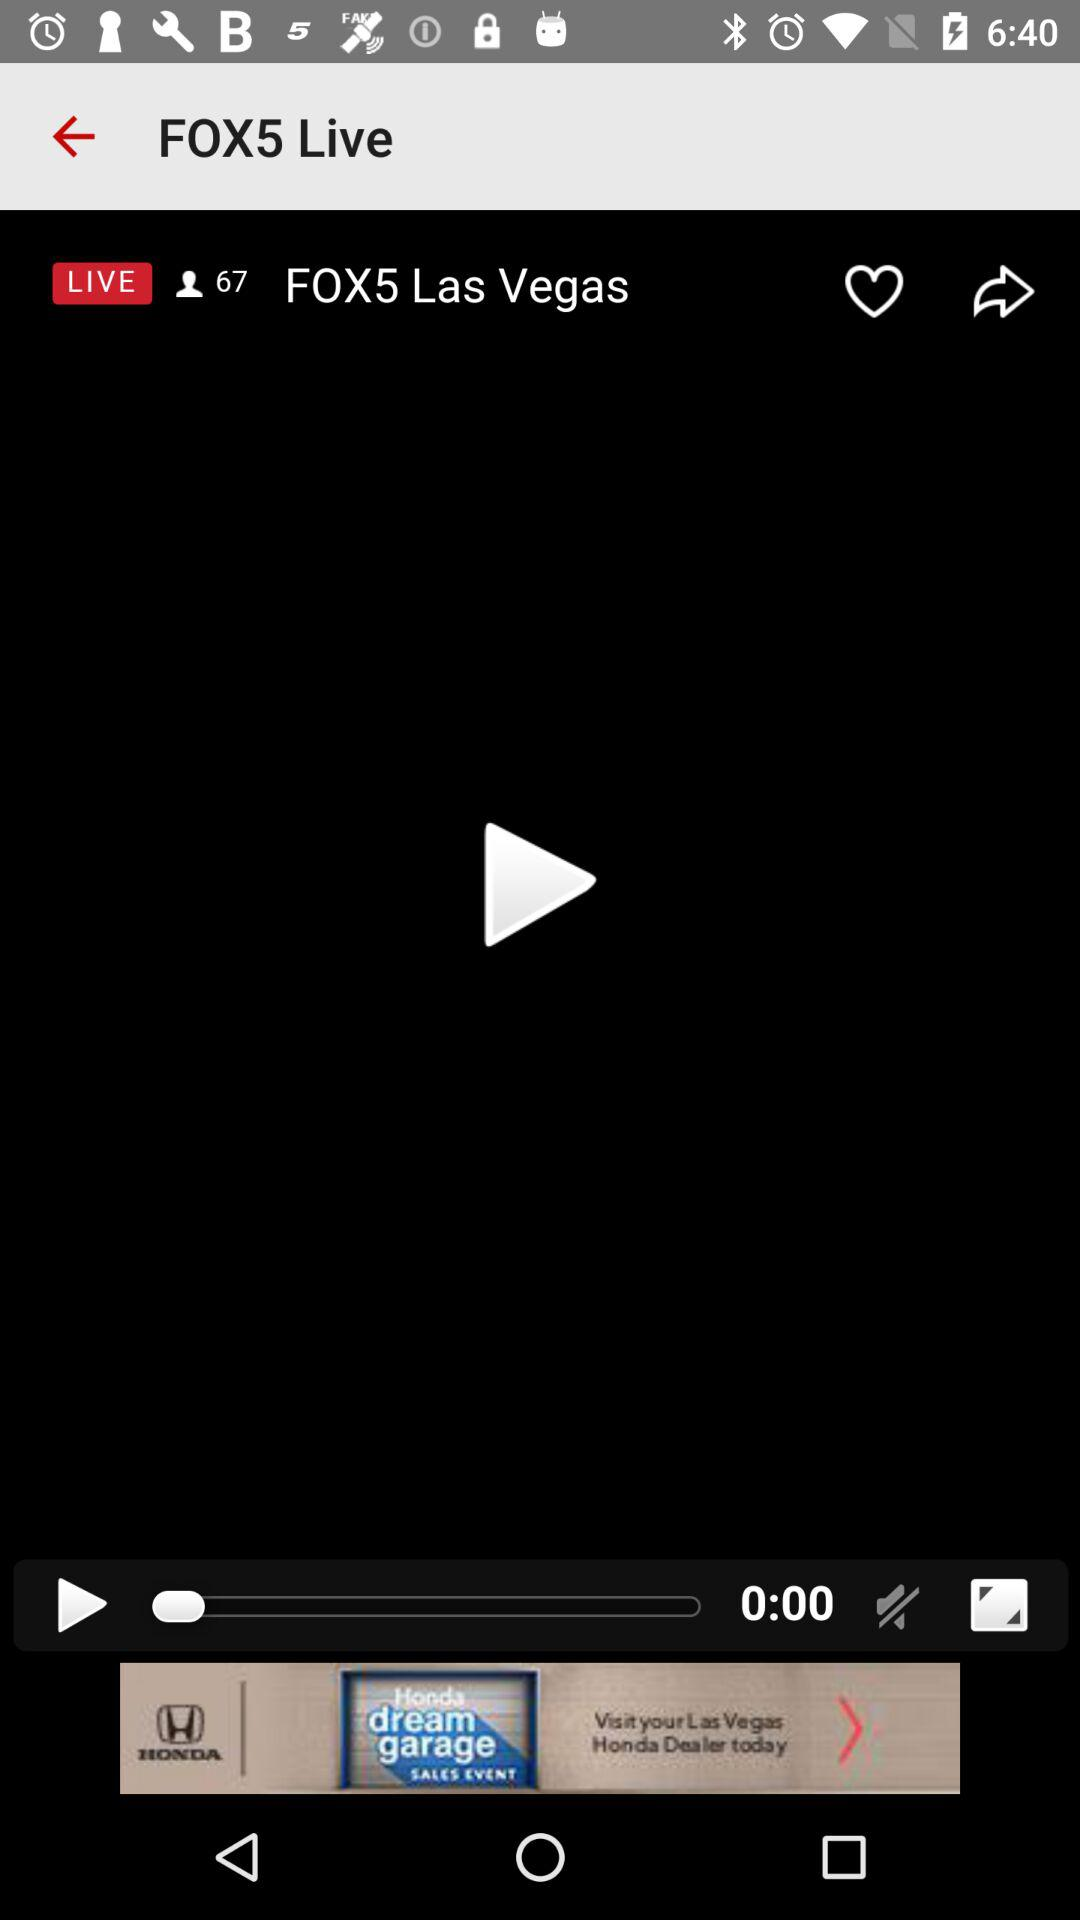How many people joined when FOX5 Las Vegas came live? There are 67 people who joined when FOX5 Las Vegas came live. 